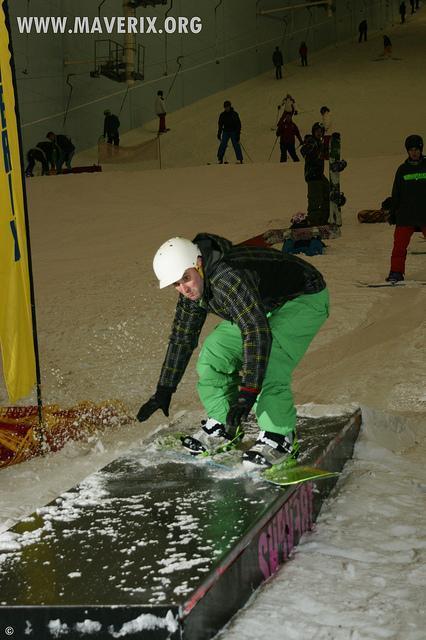How many people are visible?
Give a very brief answer. 2. 